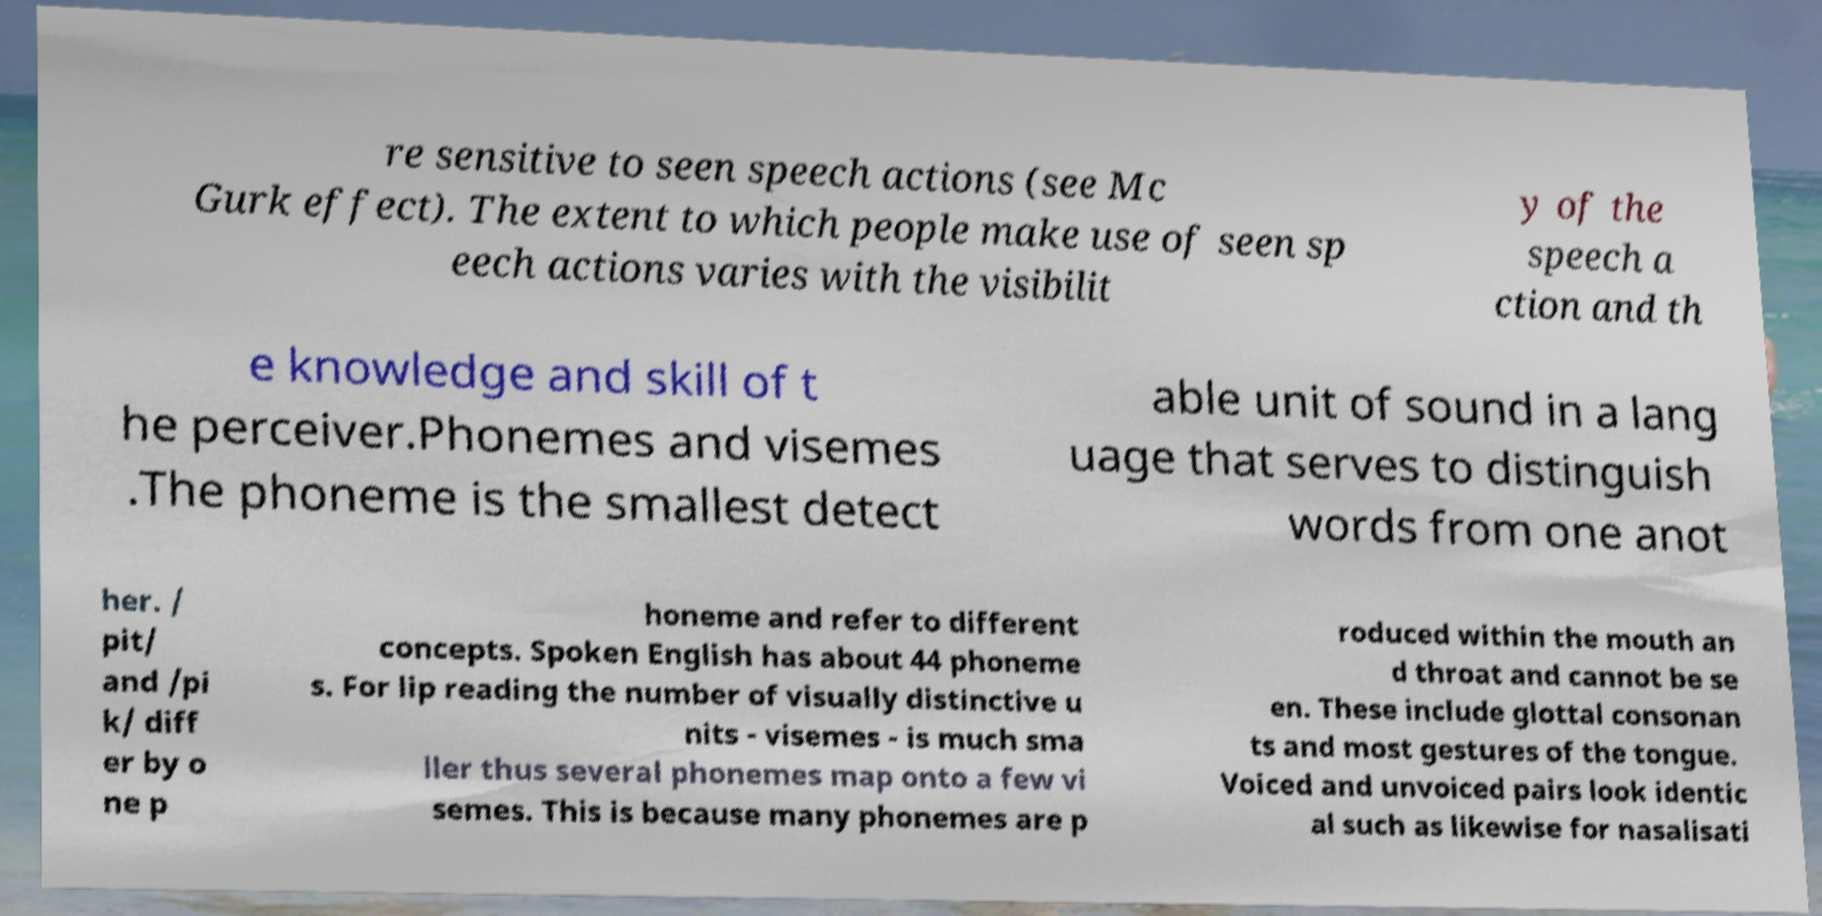Can you read and provide the text displayed in the image?This photo seems to have some interesting text. Can you extract and type it out for me? re sensitive to seen speech actions (see Mc Gurk effect). The extent to which people make use of seen sp eech actions varies with the visibilit y of the speech a ction and th e knowledge and skill of t he perceiver.Phonemes and visemes .The phoneme is the smallest detect able unit of sound in a lang uage that serves to distinguish words from one anot her. / pit/ and /pi k/ diff er by o ne p honeme and refer to different concepts. Spoken English has about 44 phoneme s. For lip reading the number of visually distinctive u nits - visemes - is much sma ller thus several phonemes map onto a few vi semes. This is because many phonemes are p roduced within the mouth an d throat and cannot be se en. These include glottal consonan ts and most gestures of the tongue. Voiced and unvoiced pairs look identic al such as likewise for nasalisati 